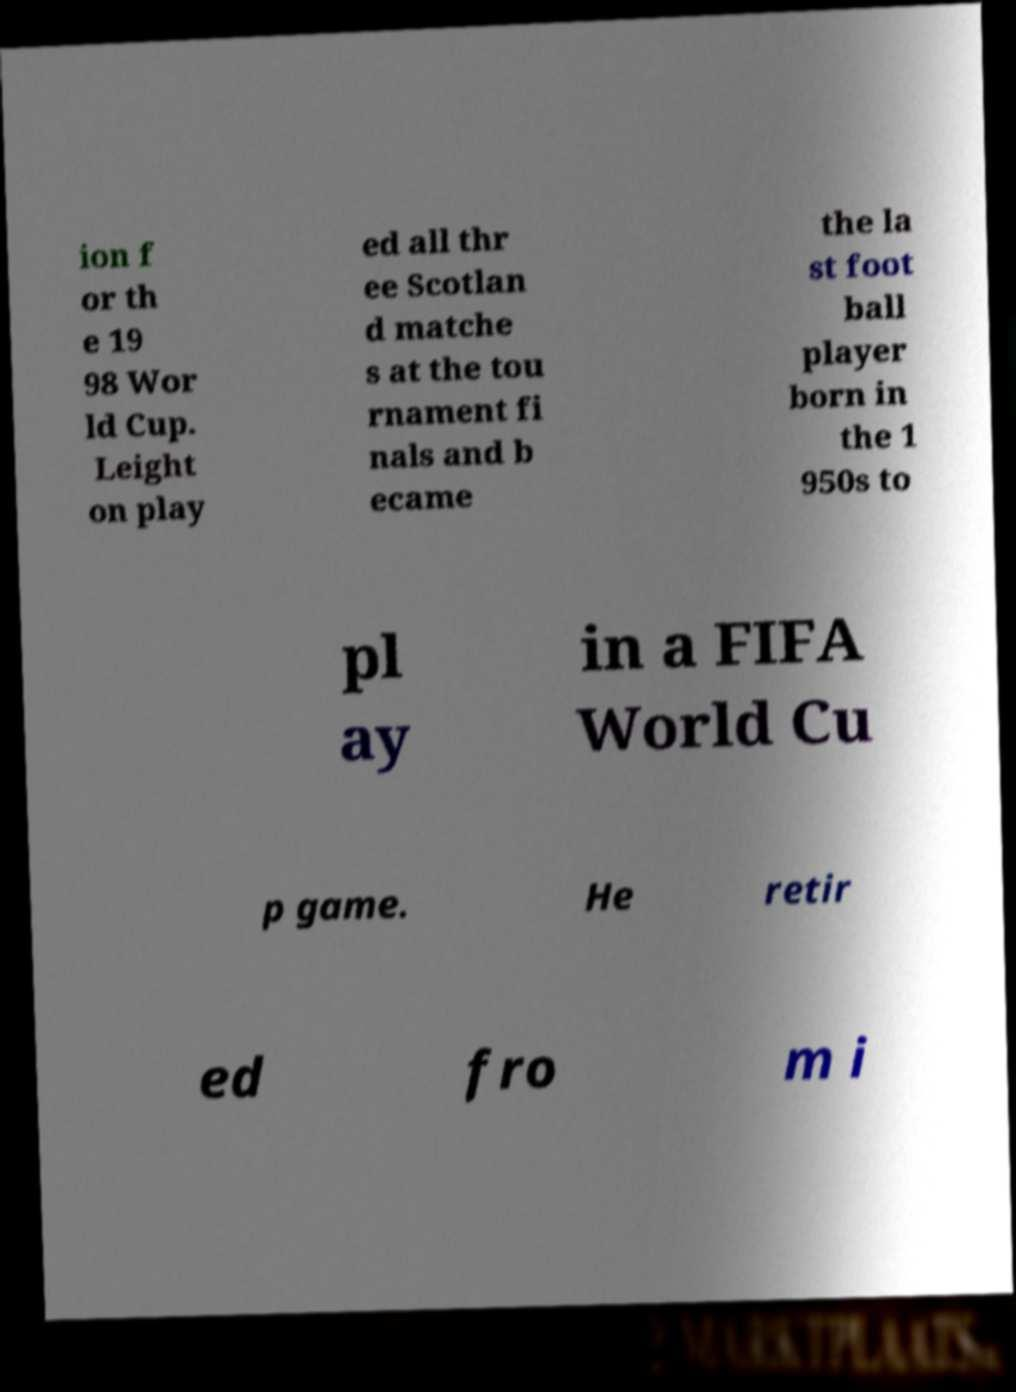Could you extract and type out the text from this image? ion f or th e 19 98 Wor ld Cup. Leight on play ed all thr ee Scotlan d matche s at the tou rnament fi nals and b ecame the la st foot ball player born in the 1 950s to pl ay in a FIFA World Cu p game. He retir ed fro m i 